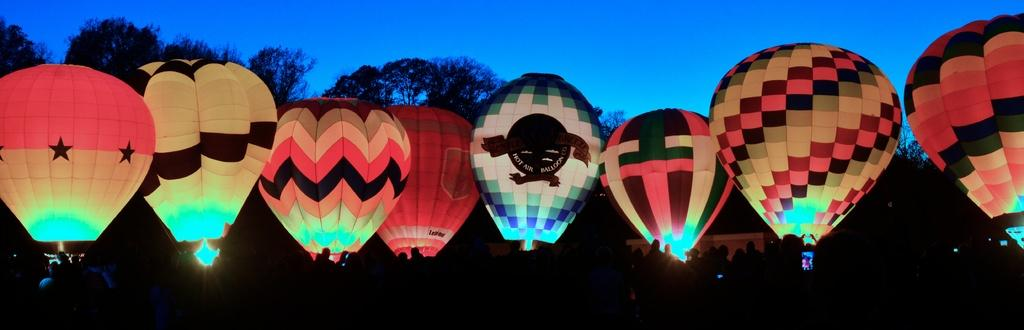What is the lighting condition at the bottom of the image? The bottom of the image is dark. What can be seen at the bottom of the image? There are people at the bottom of the image. What are the main objects in the image? There are hot air balloons in the image. What type of natural scenery is visible in the background of the image? There are trees in the background of the image. What is visible at the top of the image? The sky is visible at the top of the image. Where is the fireman located in the image? There is no fireman present in the image. What type of books can be seen on the seashore in the image? There is no seashore or books present in the image. 